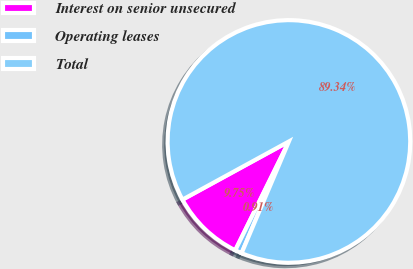Convert chart to OTSL. <chart><loc_0><loc_0><loc_500><loc_500><pie_chart><fcel>Interest on senior unsecured<fcel>Operating leases<fcel>Total<nl><fcel>9.75%<fcel>0.91%<fcel>89.34%<nl></chart> 